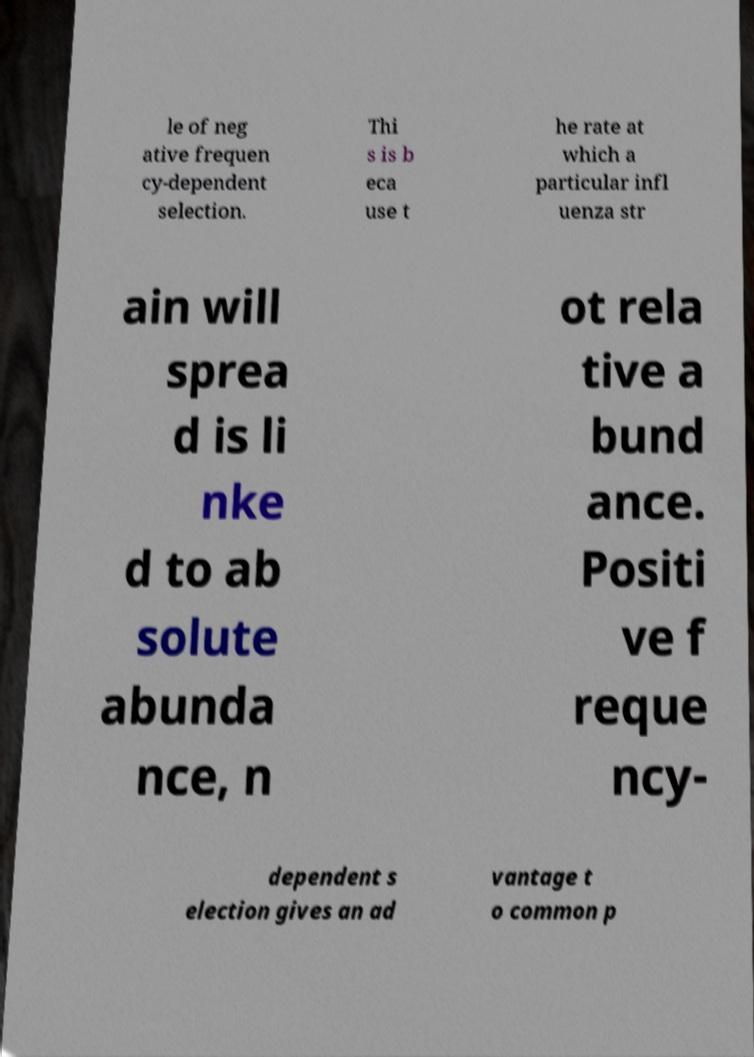Can you accurately transcribe the text from the provided image for me? le of neg ative frequen cy-dependent selection. Thi s is b eca use t he rate at which a particular infl uenza str ain will sprea d is li nke d to ab solute abunda nce, n ot rela tive a bund ance. Positi ve f reque ncy- dependent s election gives an ad vantage t o common p 